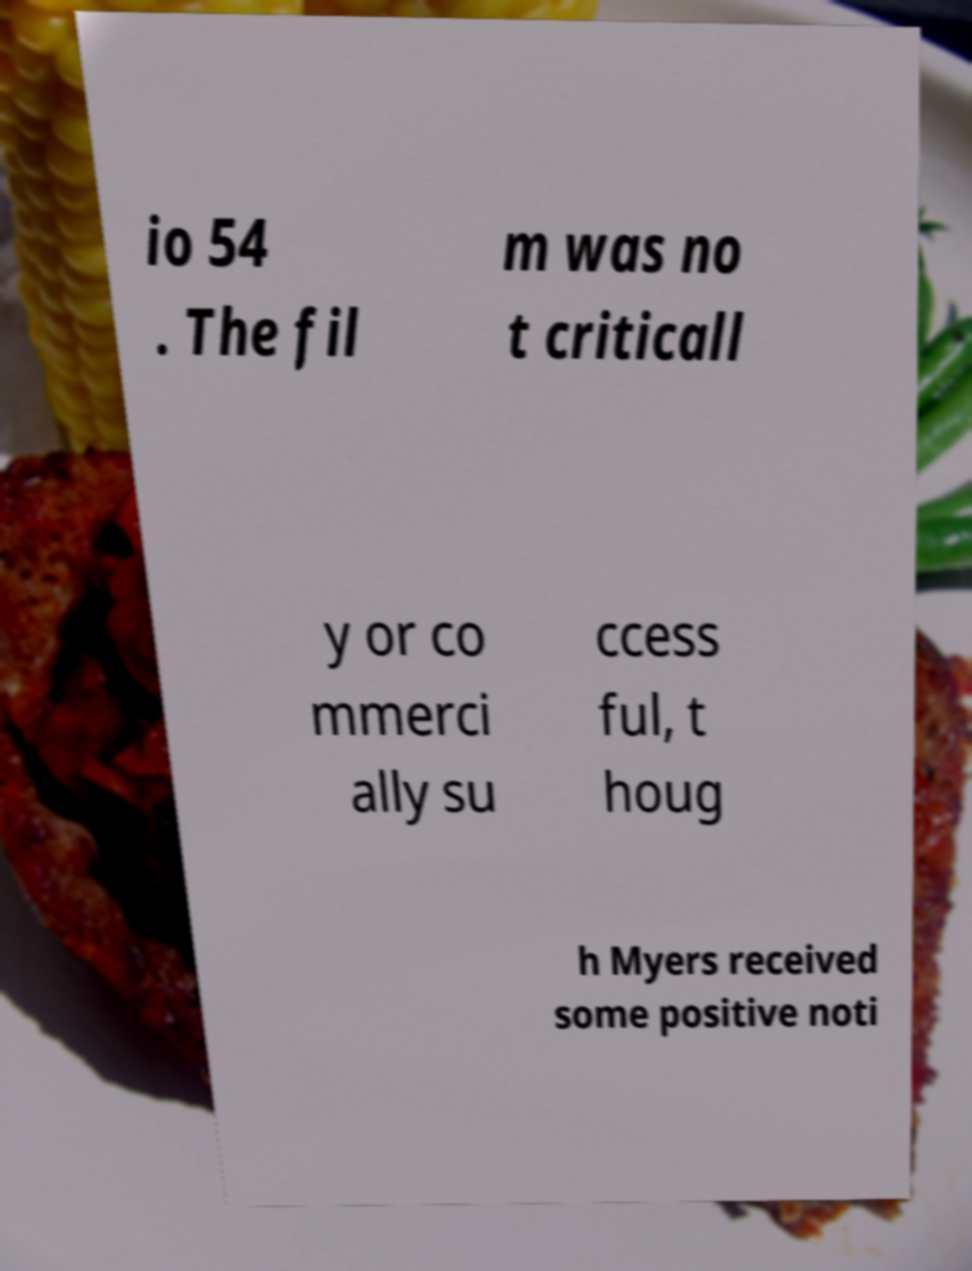Could you assist in decoding the text presented in this image and type it out clearly? io 54 . The fil m was no t criticall y or co mmerci ally su ccess ful, t houg h Myers received some positive noti 